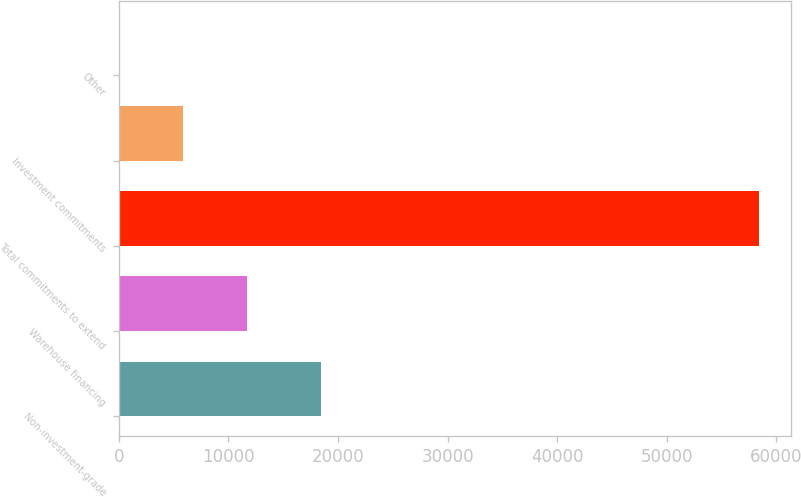Convert chart to OTSL. <chart><loc_0><loc_0><loc_500><loc_500><bar_chart><fcel>Non-investment-grade<fcel>Warehouse financing<fcel>Total commitments to extend<fcel>Investment commitments<fcel>Other<nl><fcel>18484<fcel>11694.4<fcel>58412<fcel>5854.7<fcel>15<nl></chart> 